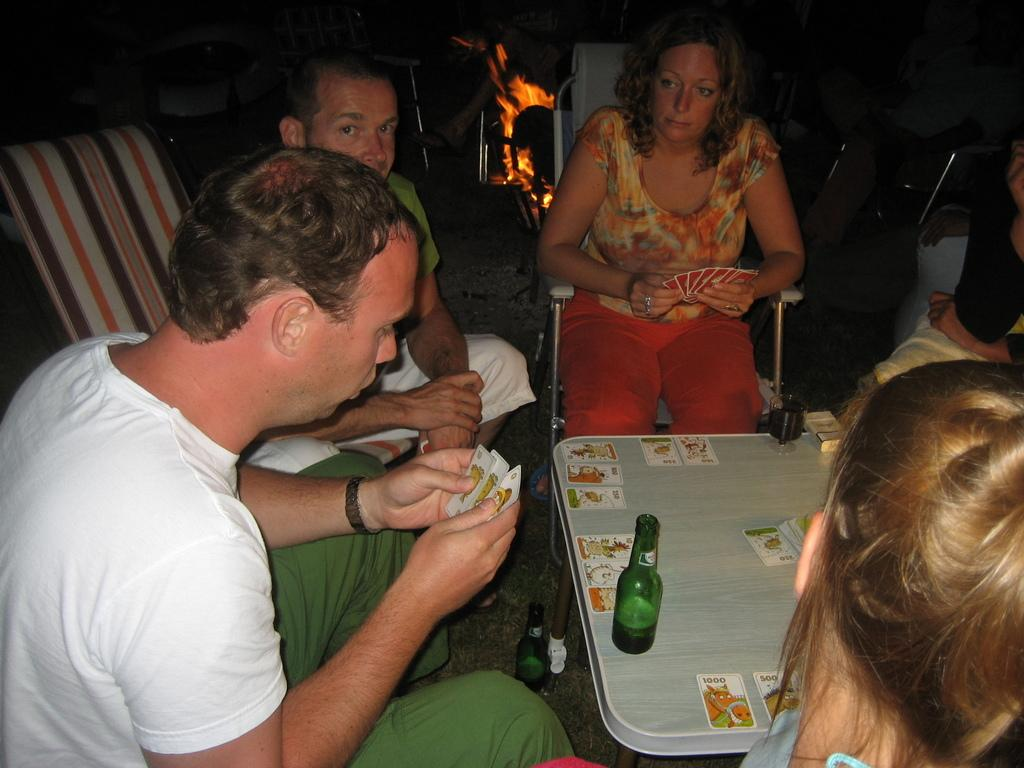What activity are the people in the image engaged in? The people in the image are playing cards. What can be seen on the table besides the people? There is a glass and cards on the table. What is visible in the background of the image? There is a camp fire and chairs in the background of the image. What type of poison is being used in the game of cards in the image? There is no poison present in the image; it is a game of cards being played by people. Can you see any bushes or a volleyball court in the image? No, there are no bushes or a volleyball court visible in the image. 